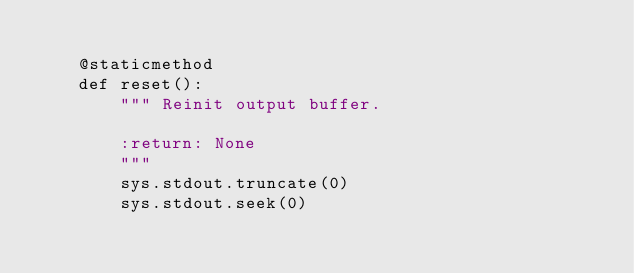<code> <loc_0><loc_0><loc_500><loc_500><_Python_>
    @staticmethod
    def reset():
        """ Reinit output buffer.

        :return: None
        """
        sys.stdout.truncate(0)
        sys.stdout.seek(0)</code> 